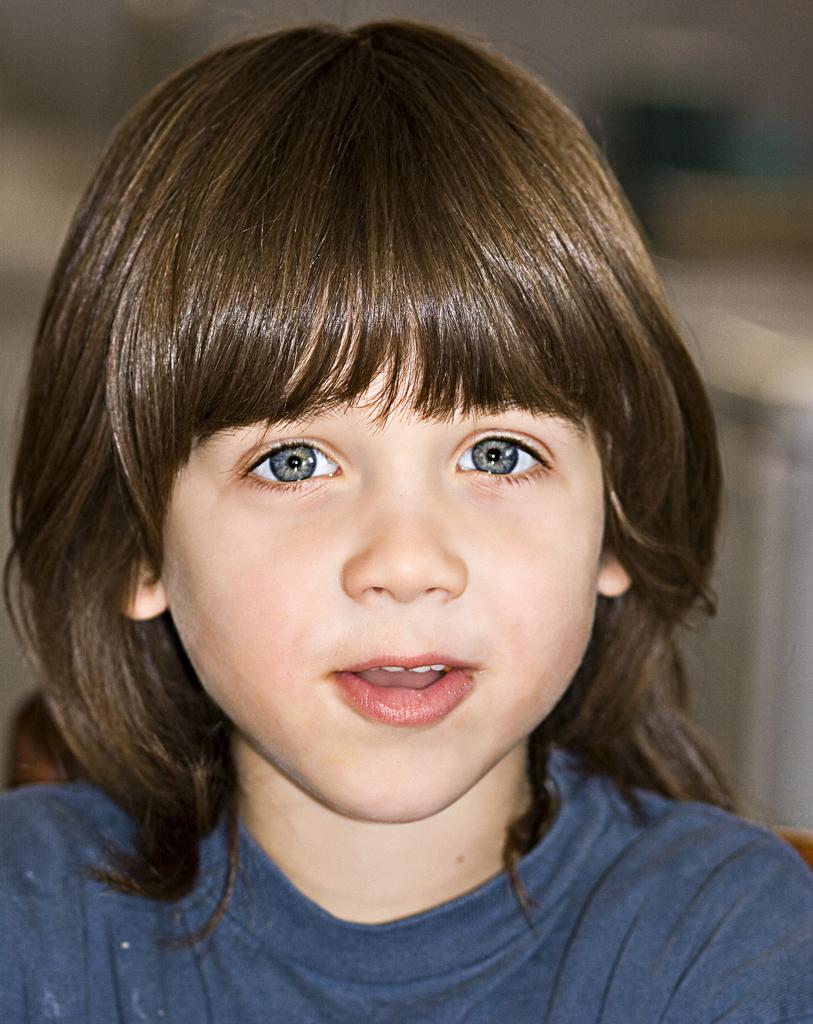What is the main subject of the image? There is a picture of a kid in the image. Can you describe the kid in the image? Unfortunately, the provided facts do not include any details about the kid's appearance or actions. Is there anything else in the image besides the picture of the kid? The provided facts do not mention any other elements in the image. What type of flowers can be seen growing low to the ground in the image? There are no flowers present in the image; it only contains a picture of a kid. 